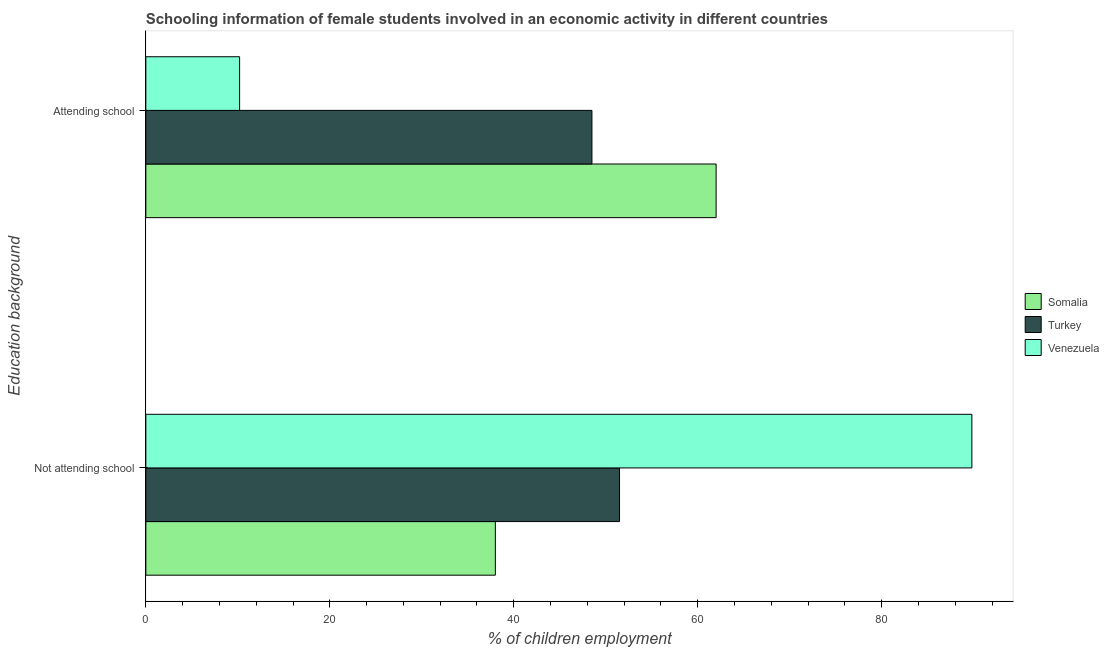How many different coloured bars are there?
Provide a short and direct response. 3. How many groups of bars are there?
Ensure brevity in your answer.  2. Are the number of bars on each tick of the Y-axis equal?
Ensure brevity in your answer.  Yes. How many bars are there on the 2nd tick from the bottom?
Make the answer very short. 3. What is the label of the 1st group of bars from the top?
Provide a succinct answer. Attending school. What is the percentage of employed females who are not attending school in Turkey?
Offer a terse response. 51.5. Across all countries, what is the maximum percentage of employed females who are attending school?
Provide a short and direct response. 62. Across all countries, what is the minimum percentage of employed females who are not attending school?
Give a very brief answer. 38. In which country was the percentage of employed females who are attending school maximum?
Provide a succinct answer. Somalia. In which country was the percentage of employed females who are not attending school minimum?
Offer a very short reply. Somalia. What is the total percentage of employed females who are attending school in the graph?
Provide a succinct answer. 120.69. What is the difference between the percentage of employed females who are attending school in Somalia and that in Venezuela?
Provide a succinct answer. 51.81. What is the difference between the percentage of employed females who are not attending school in Somalia and the percentage of employed females who are attending school in Turkey?
Provide a short and direct response. -10.5. What is the average percentage of employed females who are not attending school per country?
Ensure brevity in your answer.  59.77. What is the difference between the percentage of employed females who are attending school and percentage of employed females who are not attending school in Somalia?
Make the answer very short. 24. What is the ratio of the percentage of employed females who are not attending school in Venezuela to that in Somalia?
Offer a very short reply. 2.36. Is the percentage of employed females who are not attending school in Somalia less than that in Turkey?
Ensure brevity in your answer.  Yes. What does the 1st bar from the top in Attending school represents?
Your answer should be compact. Venezuela. What does the 2nd bar from the bottom in Attending school represents?
Offer a terse response. Turkey. How many bars are there?
Keep it short and to the point. 6. Are all the bars in the graph horizontal?
Provide a short and direct response. Yes. What is the difference between two consecutive major ticks on the X-axis?
Offer a terse response. 20. Are the values on the major ticks of X-axis written in scientific E-notation?
Ensure brevity in your answer.  No. Does the graph contain grids?
Give a very brief answer. No. How many legend labels are there?
Offer a terse response. 3. What is the title of the graph?
Provide a short and direct response. Schooling information of female students involved in an economic activity in different countries. What is the label or title of the X-axis?
Your answer should be very brief. % of children employment. What is the label or title of the Y-axis?
Your response must be concise. Education background. What is the % of children employment in Somalia in Not attending school?
Offer a very short reply. 38. What is the % of children employment in Turkey in Not attending school?
Your response must be concise. 51.5. What is the % of children employment of Venezuela in Not attending school?
Ensure brevity in your answer.  89.81. What is the % of children employment in Turkey in Attending school?
Your answer should be very brief. 48.5. What is the % of children employment in Venezuela in Attending school?
Provide a short and direct response. 10.19. Across all Education background, what is the maximum % of children employment in Somalia?
Offer a very short reply. 62. Across all Education background, what is the maximum % of children employment of Turkey?
Keep it short and to the point. 51.5. Across all Education background, what is the maximum % of children employment in Venezuela?
Make the answer very short. 89.81. Across all Education background, what is the minimum % of children employment in Turkey?
Offer a very short reply. 48.5. Across all Education background, what is the minimum % of children employment of Venezuela?
Make the answer very short. 10.19. What is the total % of children employment in Venezuela in the graph?
Your answer should be compact. 100. What is the difference between the % of children employment in Somalia in Not attending school and that in Attending school?
Make the answer very short. -24. What is the difference between the % of children employment of Turkey in Not attending school and that in Attending school?
Provide a succinct answer. 3. What is the difference between the % of children employment in Venezuela in Not attending school and that in Attending school?
Provide a succinct answer. 79.61. What is the difference between the % of children employment in Somalia in Not attending school and the % of children employment in Turkey in Attending school?
Keep it short and to the point. -10.5. What is the difference between the % of children employment in Somalia in Not attending school and the % of children employment in Venezuela in Attending school?
Your answer should be compact. 27.81. What is the difference between the % of children employment of Turkey in Not attending school and the % of children employment of Venezuela in Attending school?
Your answer should be very brief. 41.31. What is the average % of children employment of Turkey per Education background?
Provide a succinct answer. 50. What is the difference between the % of children employment in Somalia and % of children employment in Turkey in Not attending school?
Offer a terse response. -13.5. What is the difference between the % of children employment of Somalia and % of children employment of Venezuela in Not attending school?
Your answer should be very brief. -51.81. What is the difference between the % of children employment in Turkey and % of children employment in Venezuela in Not attending school?
Your response must be concise. -38.31. What is the difference between the % of children employment in Somalia and % of children employment in Venezuela in Attending school?
Provide a short and direct response. 51.81. What is the difference between the % of children employment of Turkey and % of children employment of Venezuela in Attending school?
Provide a succinct answer. 38.31. What is the ratio of the % of children employment of Somalia in Not attending school to that in Attending school?
Give a very brief answer. 0.61. What is the ratio of the % of children employment in Turkey in Not attending school to that in Attending school?
Ensure brevity in your answer.  1.06. What is the ratio of the % of children employment in Venezuela in Not attending school to that in Attending school?
Your answer should be very brief. 8.81. What is the difference between the highest and the second highest % of children employment in Somalia?
Provide a succinct answer. 24. What is the difference between the highest and the second highest % of children employment in Venezuela?
Keep it short and to the point. 79.61. What is the difference between the highest and the lowest % of children employment in Venezuela?
Provide a short and direct response. 79.61. 